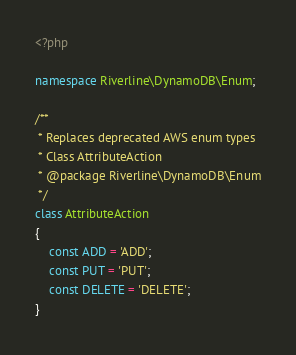<code> <loc_0><loc_0><loc_500><loc_500><_PHP_><?php

namespace Riverline\DynamoDB\Enum;

/**
 * Replaces deprecated AWS enum types
 * Class AttributeAction
 * @package Riverline\DynamoDB\Enum
 */
class AttributeAction
{
    const ADD = 'ADD';
    const PUT = 'PUT';
    const DELETE = 'DELETE';
}</code> 